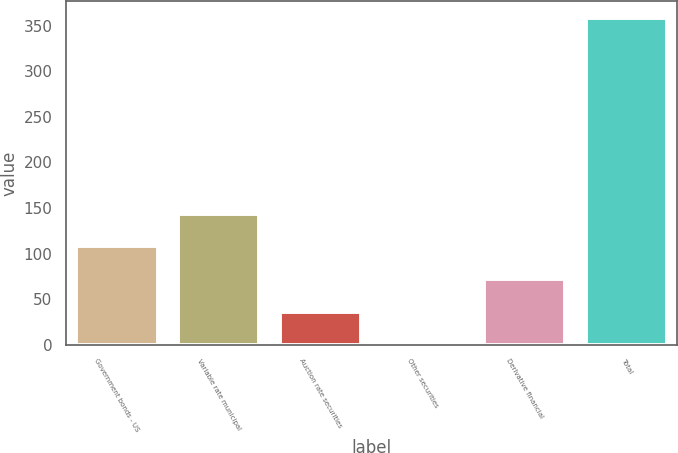Convert chart. <chart><loc_0><loc_0><loc_500><loc_500><bar_chart><fcel>Government bonds - US<fcel>Variable rate municipal<fcel>Auction rate securities<fcel>Other securities<fcel>Derivative financial<fcel>Total<nl><fcel>108.02<fcel>143.86<fcel>36.34<fcel>0.5<fcel>72.18<fcel>358.9<nl></chart> 